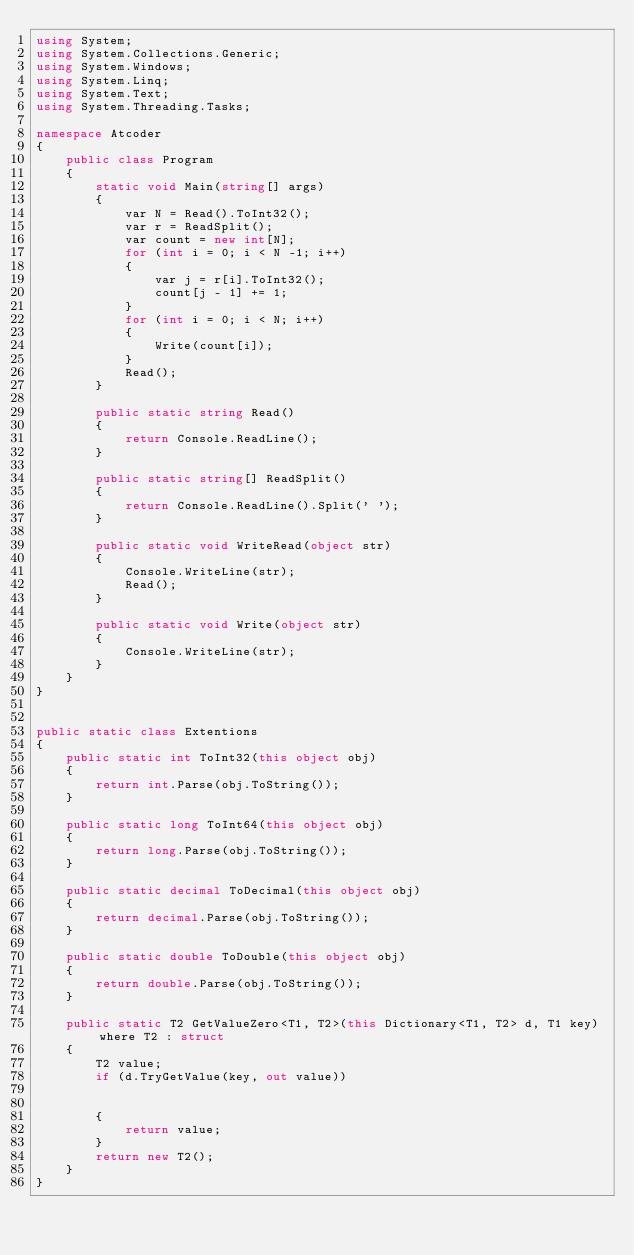<code> <loc_0><loc_0><loc_500><loc_500><_C#_>using System;
using System.Collections.Generic;
using System.Windows;
using System.Linq;
using System.Text;
using System.Threading.Tasks;

namespace Atcoder
{
    public class Program
    {
        static void Main(string[] args)
        {
            var N = Read().ToInt32();
            var r = ReadSplit();
            var count = new int[N];
            for (int i = 0; i < N -1; i++)
            {
                var j = r[i].ToInt32();
                count[j - 1] += 1;
            }
            for (int i = 0; i < N; i++)
            {
                Write(count[i]);
            }
            Read();
        }

        public static string Read()
        {
            return Console.ReadLine();
        }

        public static string[] ReadSplit()
        {
            return Console.ReadLine().Split(' ');
        }

        public static void WriteRead(object str)
        {
            Console.WriteLine(str);
            Read();
        }

        public static void Write(object str)
        {
            Console.WriteLine(str);
        }
    }
}


public static class Extentions
{
    public static int ToInt32(this object obj)
    {
        return int.Parse(obj.ToString());
    }

    public static long ToInt64(this object obj)
    {
        return long.Parse(obj.ToString());
    }

    public static decimal ToDecimal(this object obj)
    {
        return decimal.Parse(obj.ToString());
    }

    public static double ToDouble(this object obj)
    {
        return double.Parse(obj.ToString());
    }

    public static T2 GetValueZero<T1, T2>(this Dictionary<T1, T2> d, T1 key) where T2 : struct
    {
        T2 value;
        if (d.TryGetValue(key, out value))


        {
            return value;
        }
        return new T2();
    }
}

</code> 